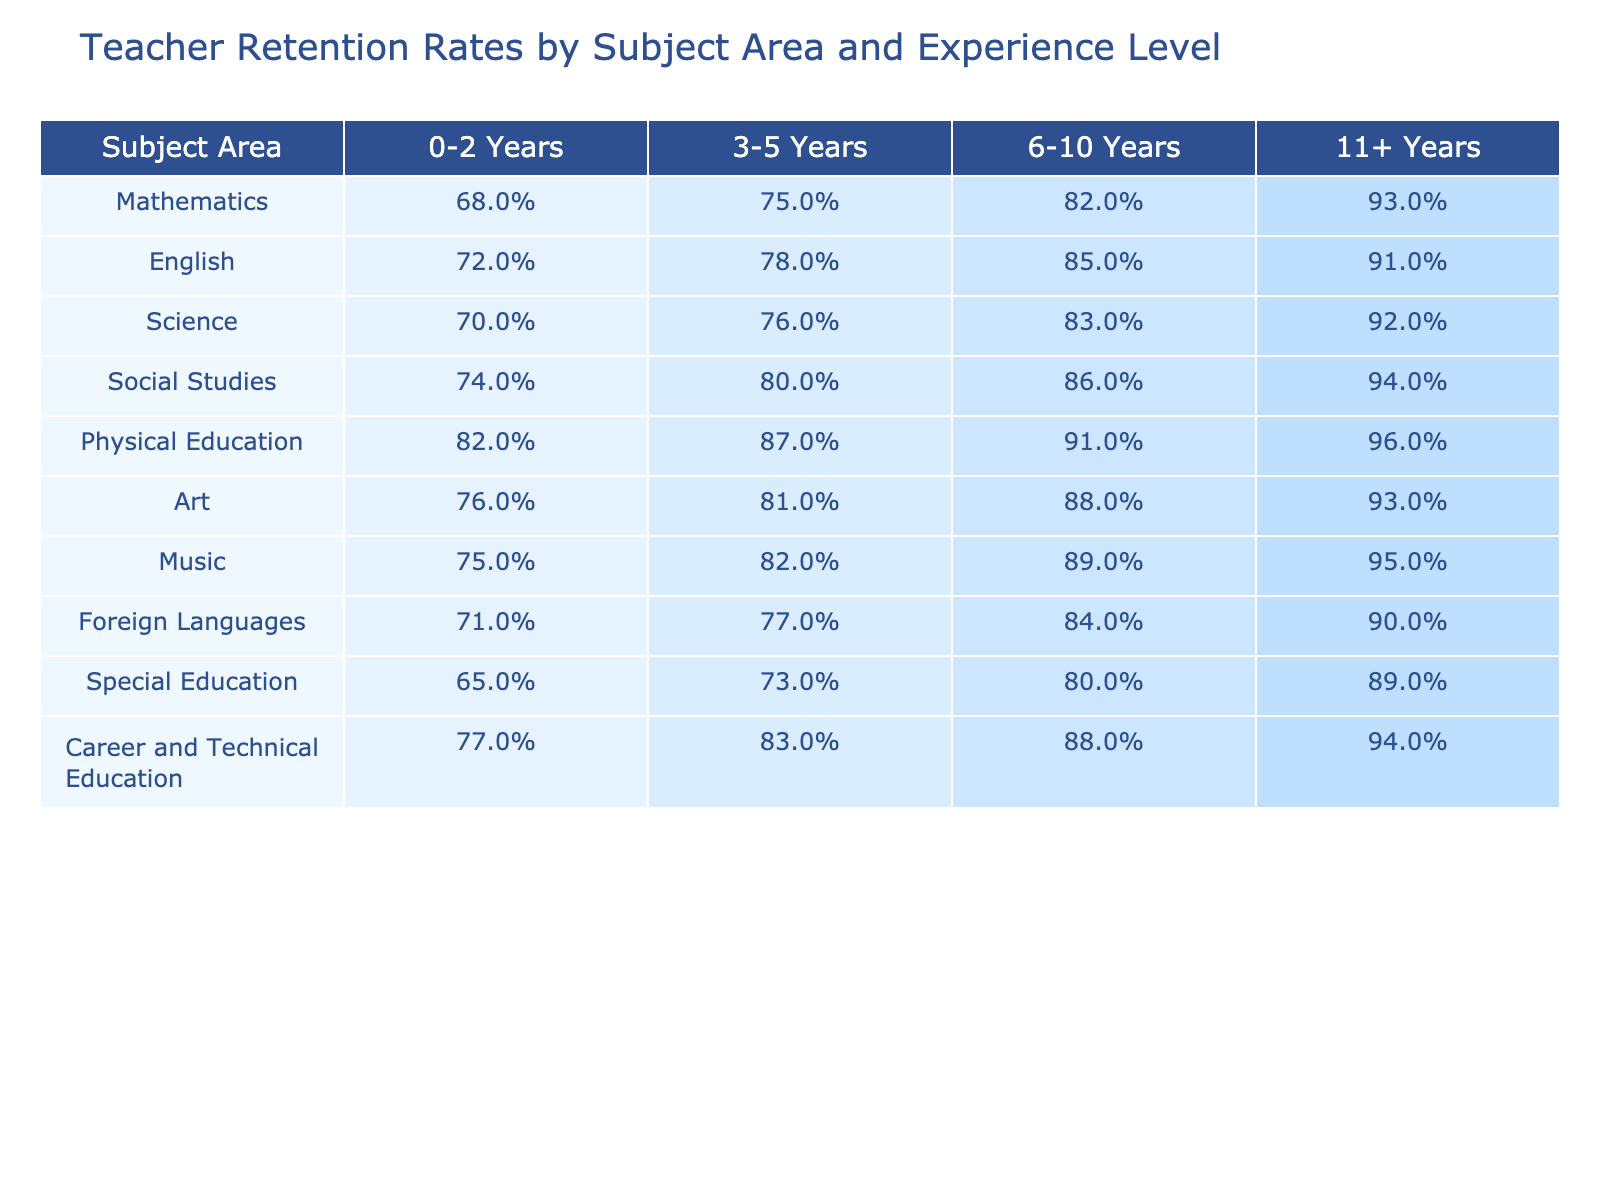What is the teacher retention rate for Mathematics teachers with 0-2 years of experience? According to the table, the retention rate for Mathematics teachers with 0-2 years of experience is listed as 68%.
Answer: 68% Which subject area has the highest retention rate for teachers with 11+ years of experience? The retention rates in the table show that Physical Education has the highest retention rate at 96% for teachers with 11+ years of experience.
Answer: Physical Education How much higher is the retention rate for English teachers with 6-10 years of experience compared to those with 0-2 years? The retention rate for English teachers with 6-10 years is 85%, and with 0-2 years is 72%. The difference is 85% - 72% = 13%.
Answer: 13% True or False: The retention rate for Special Education teachers increases consistently across all experience levels. Looking at the retention rates in the table for Special Education, they are 65%, 73%, 80%, and 89% respectively. Since these numbers increase, the statement is true.
Answer: True What is the average retention rate for Science and Social Studies teachers with 3-5 years of experience? For Science, the retention rate is 76% and for Social Studies, it is 80%. The average is calculated as (76% + 80%) / 2 = 78%.
Answer: 78% Which subject area shows the least retention for teachers with 0-2 years of experience, and what is that rate? The table lists Special Education as having the lowest retention rate of 65% for teachers with 0-2 years of experience.
Answer: Special Education, 65% If a school hired 100 new English teachers, how many would likely remain after 3-5 years? The retention rate for English teachers after 3-5 years is 78%. Thus, if 100 new teachers are hired, approximately 78 would remain after 3-5 years (100 * 0.78 = 78).
Answer: 78 Which two subject areas have the same retention rate for teachers with 11+ years of experience, and what is that rate? By examining the table, Social Studies and Music both have a retention rate of 94% for teachers with 11+ years of experience.
Answer: Social Studies and Music, 94% What is the difference in retention rates between Career and Technical Education and Foreign Languages for teachers with 11+ years of experience? The retention rate for Career and Technical Education is 94%, while for Foreign Languages it is 90%. The difference is 94% - 90% = 4%.
Answer: 4% Is the retention rate for Physical Education teachers with 0-2 years of experience higher than that of Mathematics teachers? The retention rate for Physical Education teachers with 0-2 years is 82% and for Mathematics, it is 68%. Since 82% > 68%, the statement is true.
Answer: True 